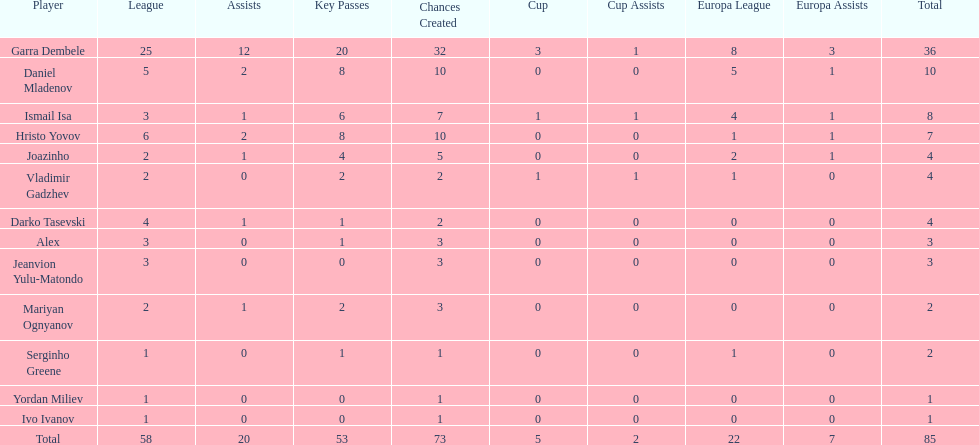How many players had a total of 4? 3. 